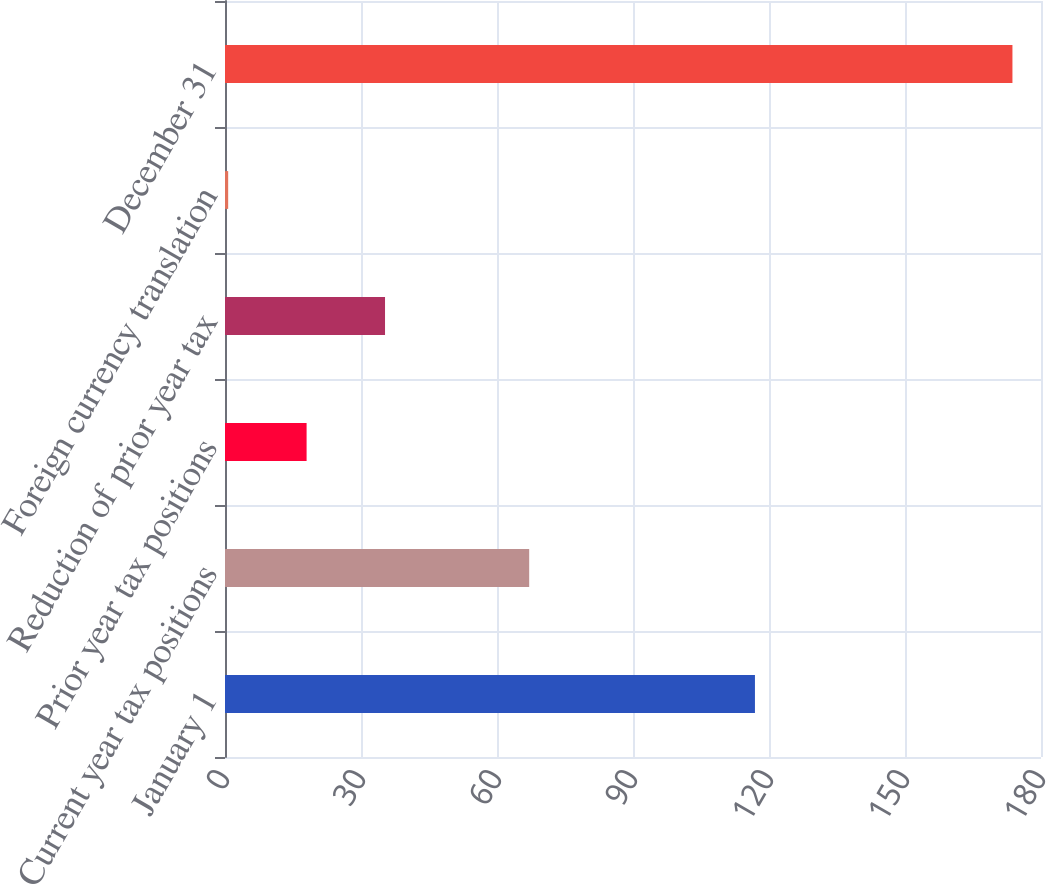Convert chart to OTSL. <chart><loc_0><loc_0><loc_500><loc_500><bar_chart><fcel>January 1<fcel>Current year tax positions<fcel>Prior year tax positions<fcel>Reduction of prior year tax<fcel>Foreign currency translation<fcel>December 31<nl><fcel>116.9<fcel>67.1<fcel>18<fcel>35.3<fcel>0.7<fcel>173.7<nl></chart> 